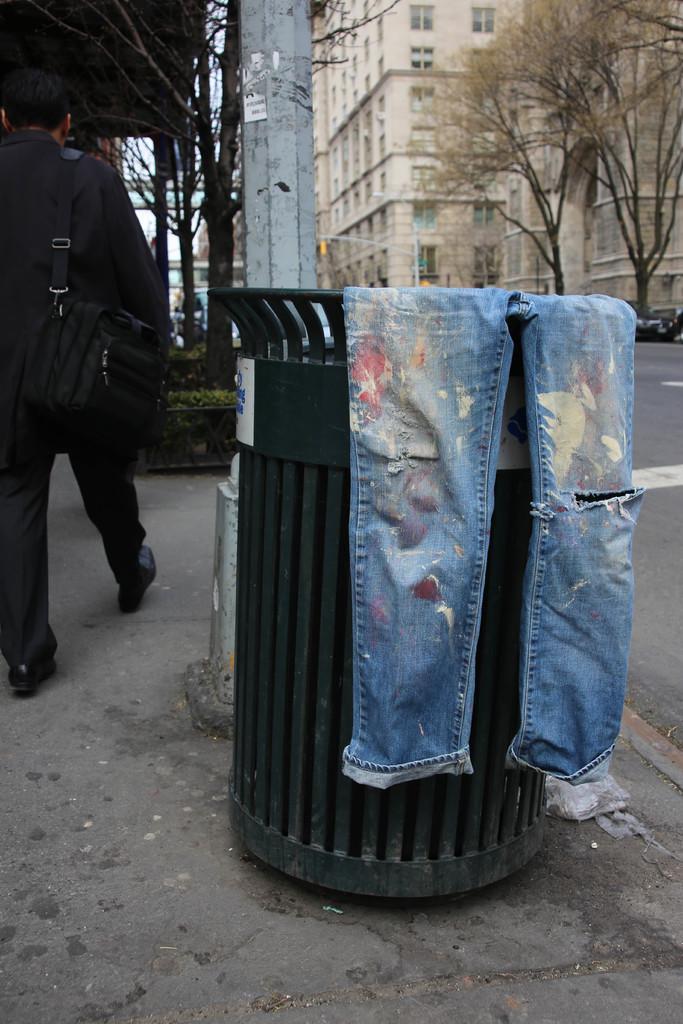Describe this image in one or two sentences. There is a torn jeans on a trash bin. A man is walking at the left wearing suit and a bag. There are trees, pole and buildings at the back. 